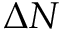Convert formula to latex. <formula><loc_0><loc_0><loc_500><loc_500>\Delta N</formula> 